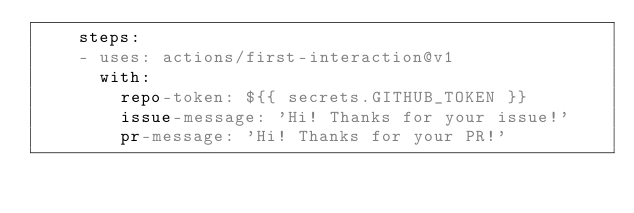Convert code to text. <code><loc_0><loc_0><loc_500><loc_500><_YAML_>    steps:
    - uses: actions/first-interaction@v1
      with:
        repo-token: ${{ secrets.GITHUB_TOKEN }}
        issue-message: 'Hi! Thanks for your issue!'
        pr-message: 'Hi! Thanks for your PR!'
</code> 